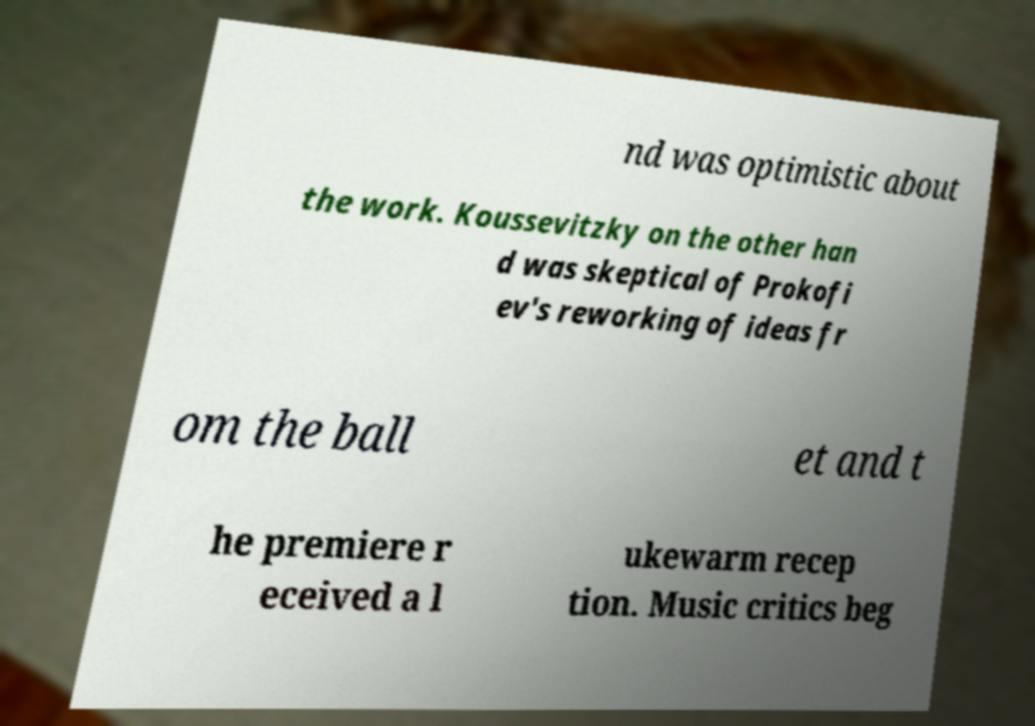Could you assist in decoding the text presented in this image and type it out clearly? nd was optimistic about the work. Koussevitzky on the other han d was skeptical of Prokofi ev's reworking of ideas fr om the ball et and t he premiere r eceived a l ukewarm recep tion. Music critics beg 